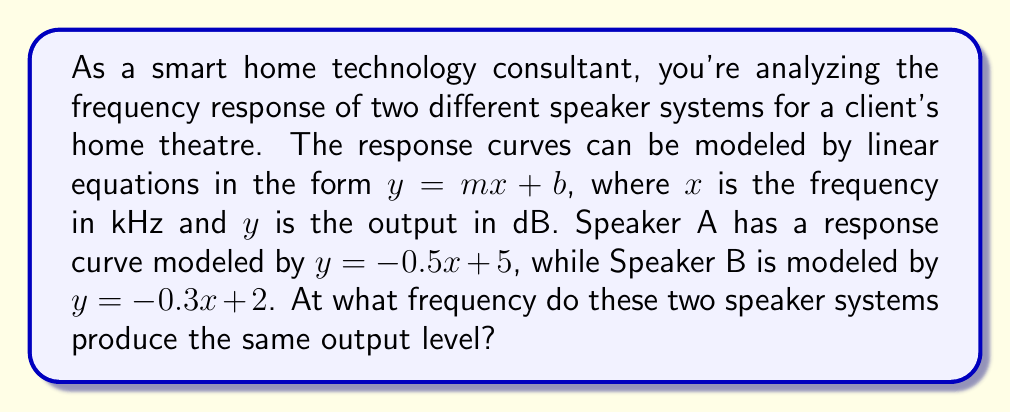Give your solution to this math problem. To solve this problem, we need to find the point of intersection between the two linear equations representing the frequency response curves of the speakers. This can be done by setting the equations equal to each other and solving for $x$.

Let's start with the given equations:
Speaker A: $y = -0.5x + 5$
Speaker B: $y = -0.3x + 2$

At the point of intersection, the $y$ values (output levels) will be equal, so we can set the equations equal to each other:

$$-0.5x + 5 = -0.3x + 2$$

Now, let's solve for $x$:

1) First, subtract $-0.3x$ from both sides:
   $$-0.2x + 5 = 2$$

2) Subtract 5 from both sides:
   $$-0.2x = -3$$

3) Divide both sides by -0.2:
   $$x = 15$$

Therefore, the two speaker systems produce the same output level at a frequency of 15 kHz.

To verify, we can plug this value back into both original equations:

For Speaker A: $y = -0.5(15) + 5 = -7.5 + 5 = -2.5$
For Speaker B: $y = -0.3(15) + 2 = -4.5 + 2 = -2.5$

As we can see, both equations yield the same output of -2.5 dB at 15 kHz, confirming our solution.
Answer: The two speaker systems produce the same output level at a frequency of 15 kHz. 